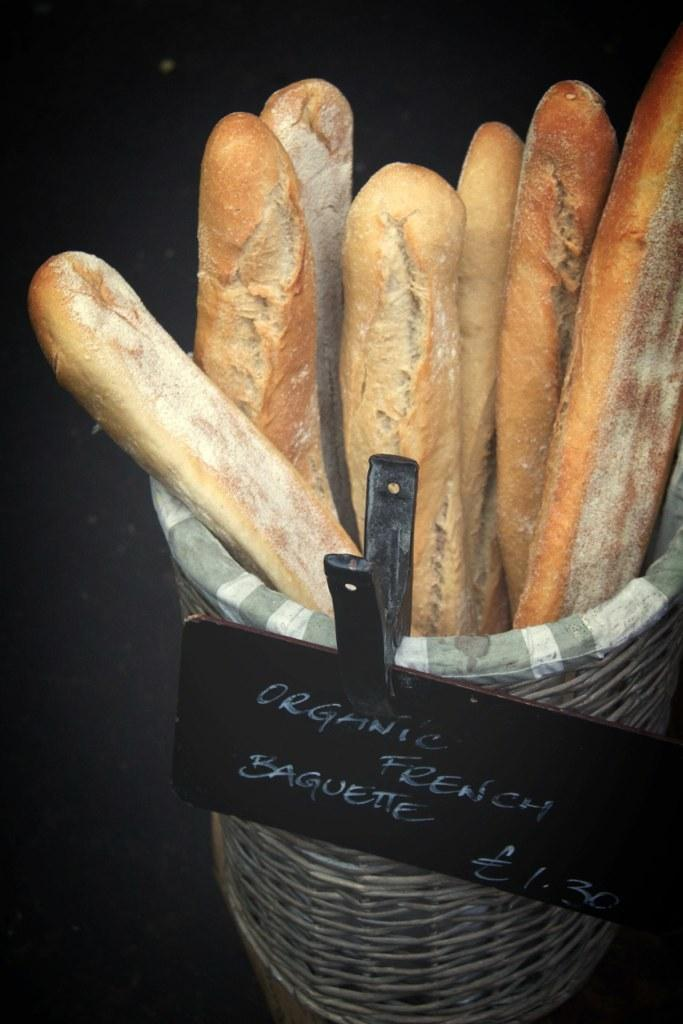What object is present in the image that can hold items? There is a basket in the image that can hold items. Is there any additional information about the basket? Yes, the basket has a name board clipped on it. What type of items are inside the basket? There are breads inside the basket. Are there any cats or rats visible in the image? No, there are no cats or rats visible in the image. What type of frame is used to hold the name board on the basket? There is no frame mentioned or visible in the image; the name board is simply clipped onto the basket. 